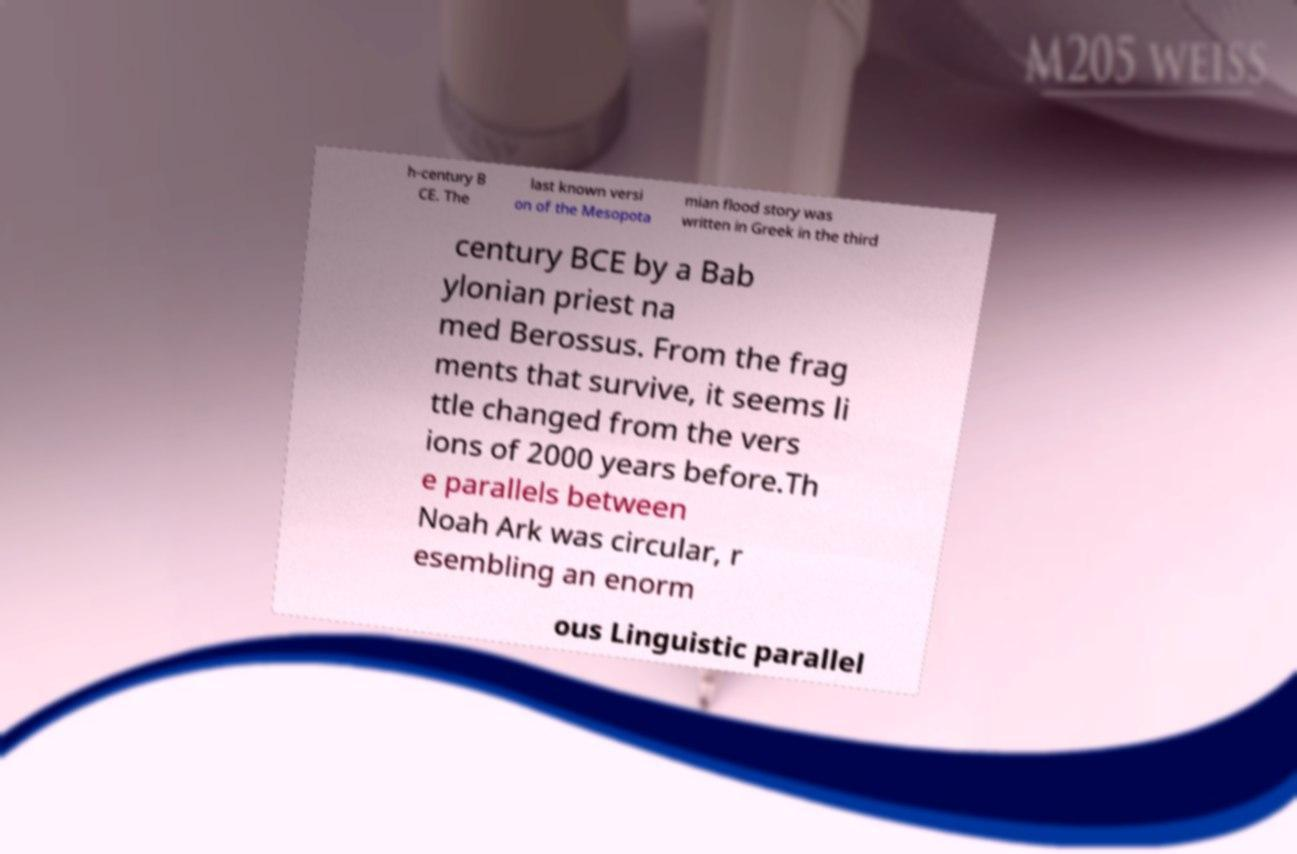Can you accurately transcribe the text from the provided image for me? h-century B CE. The last known versi on of the Mesopota mian flood story was written in Greek in the third century BCE by a Bab ylonian priest na med Berossus. From the frag ments that survive, it seems li ttle changed from the vers ions of 2000 years before.Th e parallels between Noah Ark was circular, r esembling an enorm ous Linguistic parallel 